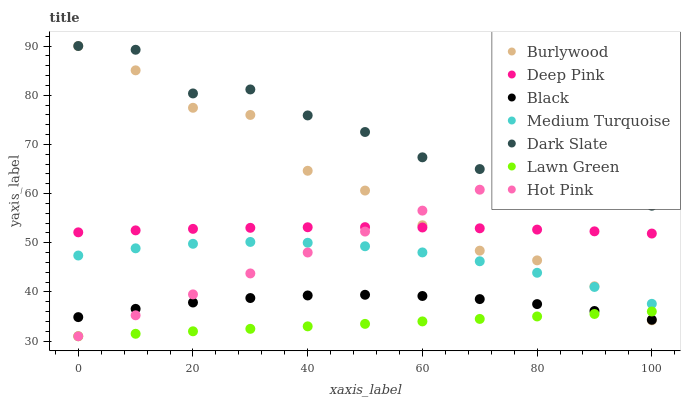Does Lawn Green have the minimum area under the curve?
Answer yes or no. Yes. Does Dark Slate have the maximum area under the curve?
Answer yes or no. Yes. Does Deep Pink have the minimum area under the curve?
Answer yes or no. No. Does Deep Pink have the maximum area under the curve?
Answer yes or no. No. Is Lawn Green the smoothest?
Answer yes or no. Yes. Is Burlywood the roughest?
Answer yes or no. Yes. Is Deep Pink the smoothest?
Answer yes or no. No. Is Deep Pink the roughest?
Answer yes or no. No. Does Lawn Green have the lowest value?
Answer yes or no. Yes. Does Deep Pink have the lowest value?
Answer yes or no. No. Does Dark Slate have the highest value?
Answer yes or no. Yes. Does Deep Pink have the highest value?
Answer yes or no. No. Is Black less than Medium Turquoise?
Answer yes or no. Yes. Is Deep Pink greater than Lawn Green?
Answer yes or no. Yes. Does Deep Pink intersect Hot Pink?
Answer yes or no. Yes. Is Deep Pink less than Hot Pink?
Answer yes or no. No. Is Deep Pink greater than Hot Pink?
Answer yes or no. No. Does Black intersect Medium Turquoise?
Answer yes or no. No. 